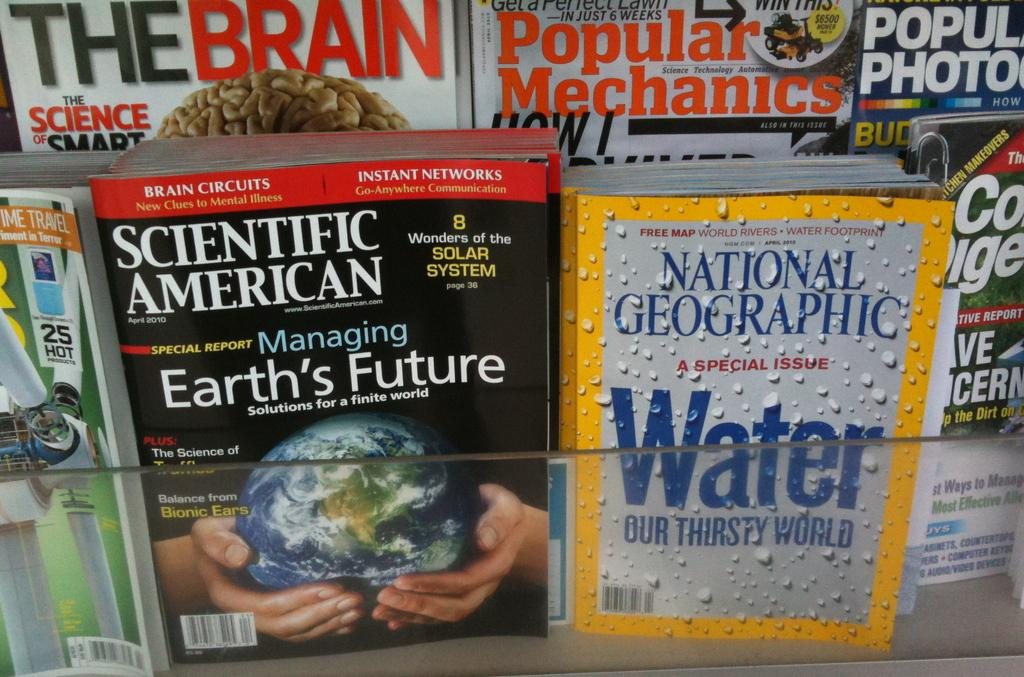Provide a one-sentence caption for the provided image. A bunch of magazines are displayed such as Scientific American and National Geographic. 